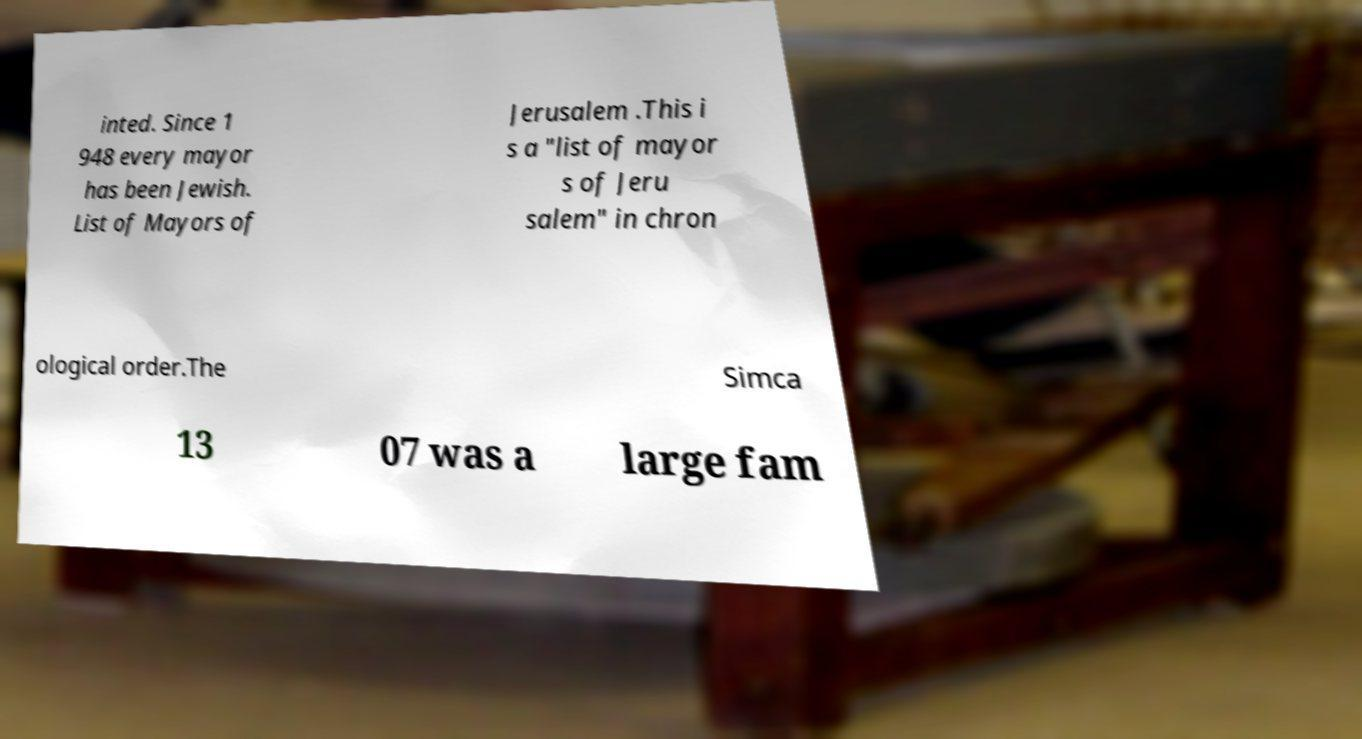I need the written content from this picture converted into text. Can you do that? inted. Since 1 948 every mayor has been Jewish. List of Mayors of Jerusalem .This i s a "list of mayor s of Jeru salem" in chron ological order.The Simca 13 07 was a large fam 